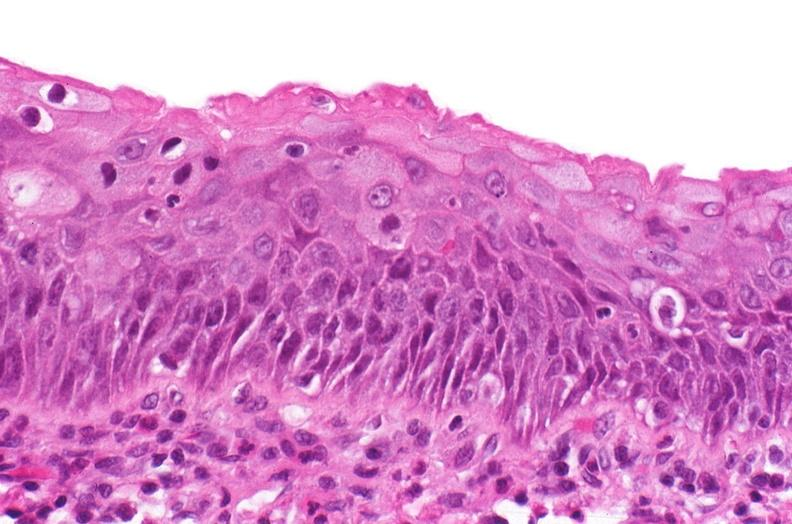where is this?
Answer the question using a single word or phrase. Urinary 